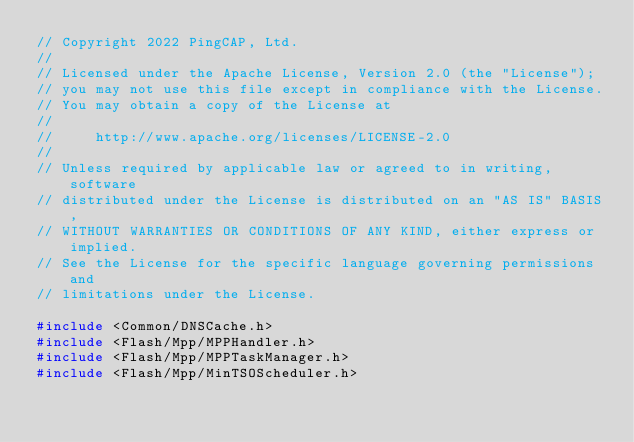Convert code to text. <code><loc_0><loc_0><loc_500><loc_500><_C++_>// Copyright 2022 PingCAP, Ltd.
//
// Licensed under the Apache License, Version 2.0 (the "License");
// you may not use this file except in compliance with the License.
// You may obtain a copy of the License at
//
//     http://www.apache.org/licenses/LICENSE-2.0
//
// Unless required by applicable law or agreed to in writing, software
// distributed under the License is distributed on an "AS IS" BASIS,
// WITHOUT WARRANTIES OR CONDITIONS OF ANY KIND, either express or implied.
// See the License for the specific language governing permissions and
// limitations under the License.

#include <Common/DNSCache.h>
#include <Flash/Mpp/MPPHandler.h>
#include <Flash/Mpp/MPPTaskManager.h>
#include <Flash/Mpp/MinTSOScheduler.h></code> 